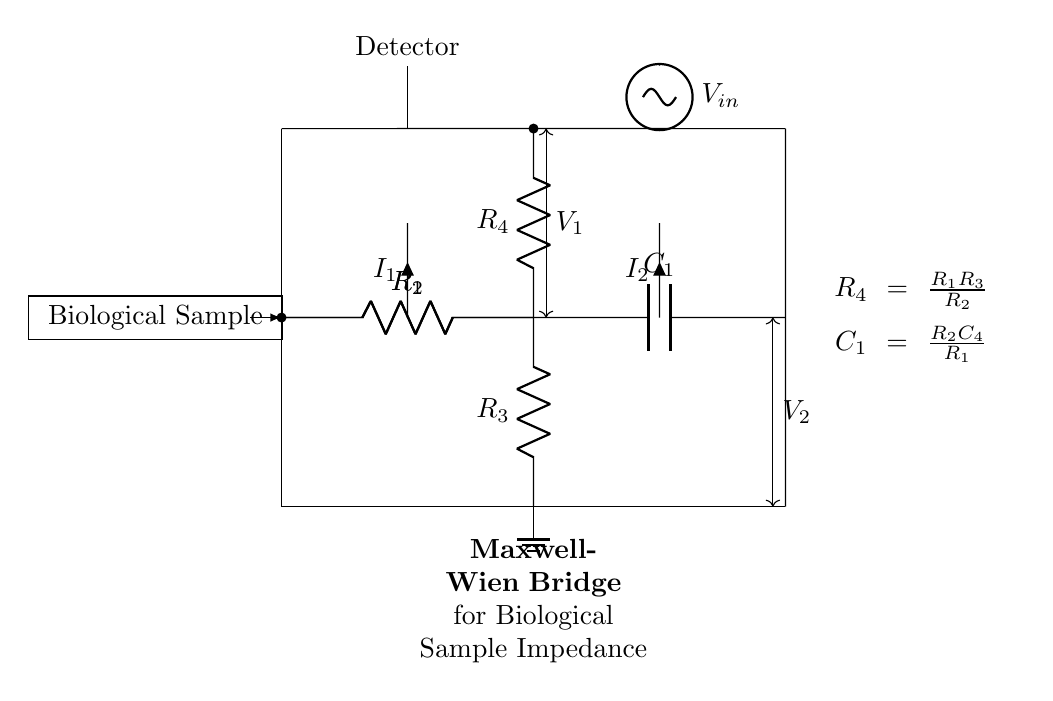What is the purpose of the Maxwell-Wien bridge? The Maxwell-Wien bridge is used for accurately measuring the impedance of biological samples, which may include both resistance and capacitance.
Answer: Accurate impedance measurement What component is at the top left of the circuit? The component at the top left of the circuit is a resistor labeled R1, which is part of the impedance measurement setup.
Answer: Resistor R1 How many resistors are present in the circuit? There are four resistors in the circuit: R1, R2, R3, and R4.
Answer: Four Which component is responsible for the electrical voltage input? The component responsible for the electrical voltage input is the voltage source labeled Vin located on the right side of the circuit.
Answer: Voltage source Vin How is the relationship between R4 and R1, R2, and R3 defined? R4 is calculated using the equation R4 equals the product of R1 and R3 divided by R2, indicating its dependence on these resistors for balancing the bridge.
Answer: R4 = R1R3/R2 What is connected to the detector in the circuit? The detector is connected to a node where voltage V1 is measured, reflecting the condition of the bridge circuit regarding the impedance of the biological sample.
Answer: Voltage V1 What does the current labeled I1 indicate? The current labeled I1 indicates the flow of electric charge through the branch involving R1 and R2 up to the central node where the bridge is balanced.
Answer: Flow through R1 and R2 